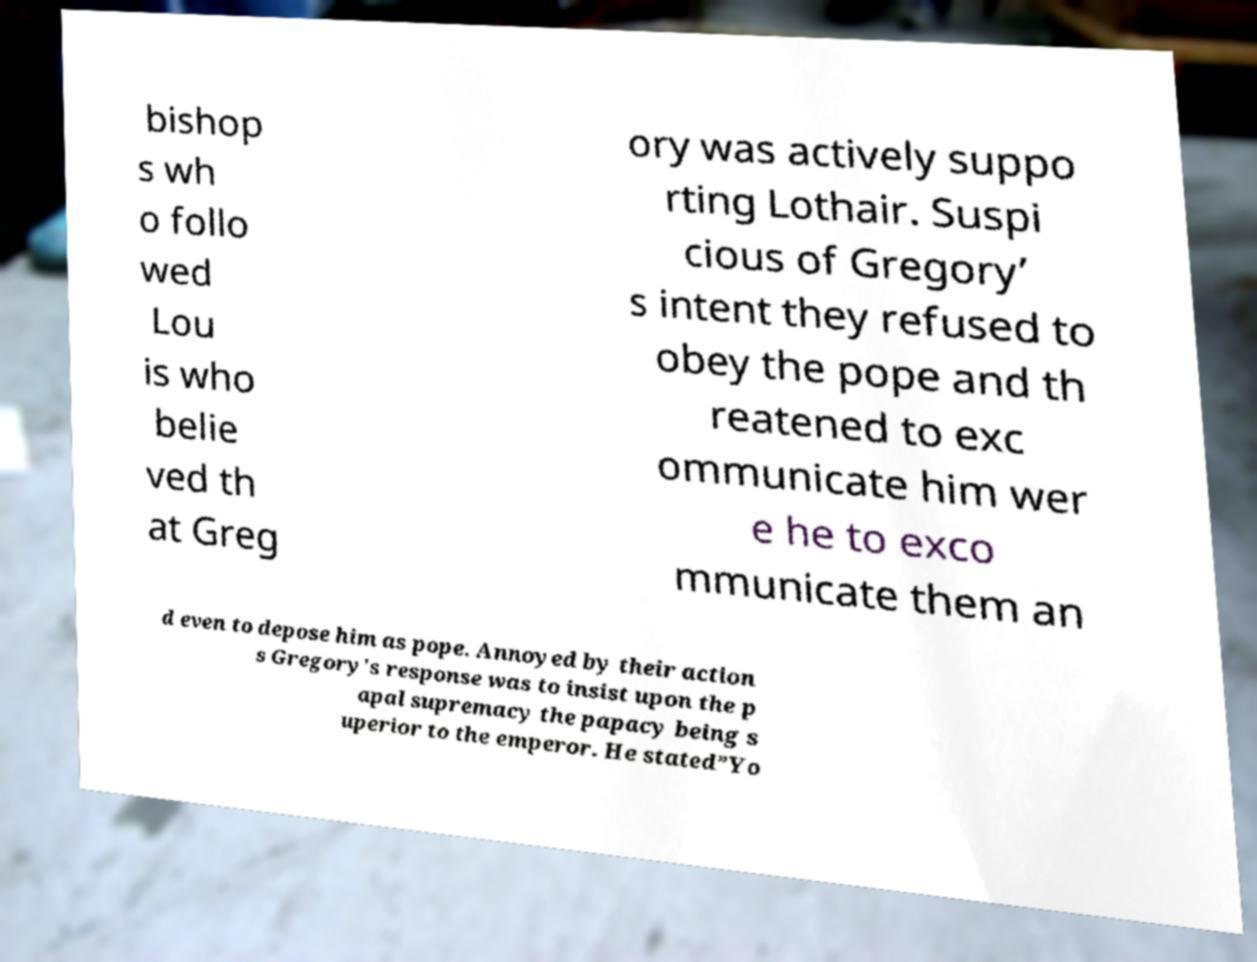I need the written content from this picture converted into text. Can you do that? bishop s wh o follo wed Lou is who belie ved th at Greg ory was actively suppo rting Lothair. Suspi cious of Gregory’ s intent they refused to obey the pope and th reatened to exc ommunicate him wer e he to exco mmunicate them an d even to depose him as pope. Annoyed by their action s Gregory's response was to insist upon the p apal supremacy the papacy being s uperior to the emperor. He stated”Yo 